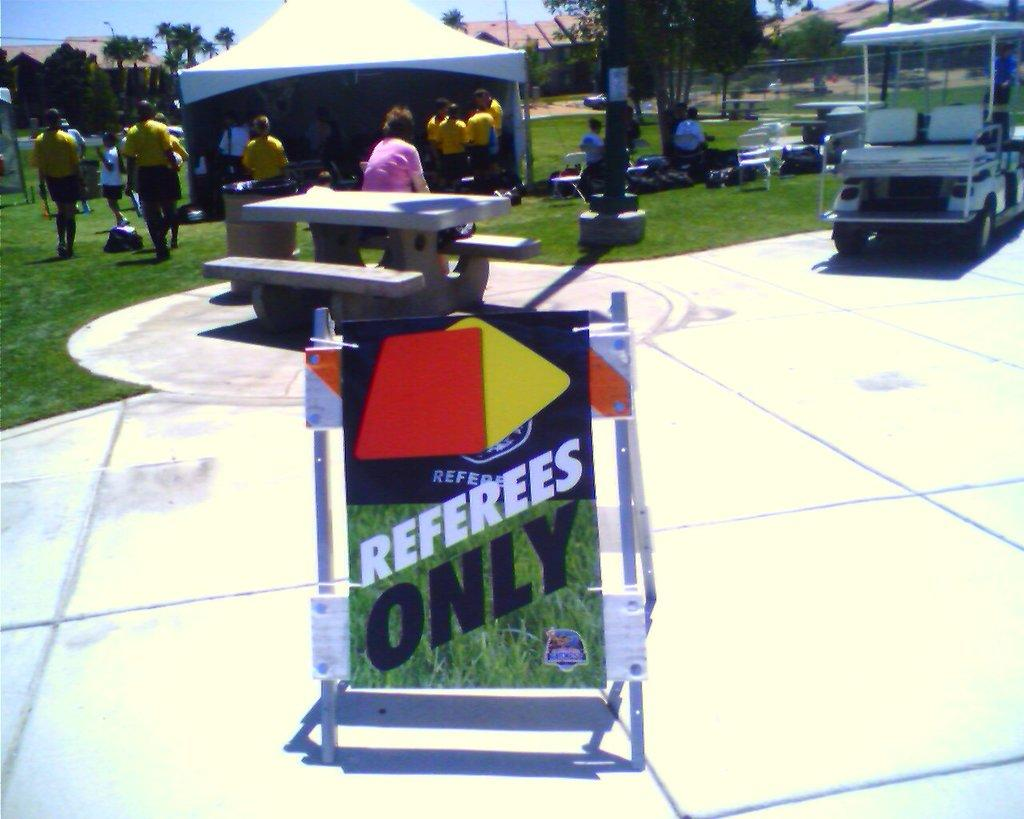<image>
Share a concise interpretation of the image provided. A sign on the sidewalk has the words referees only. 